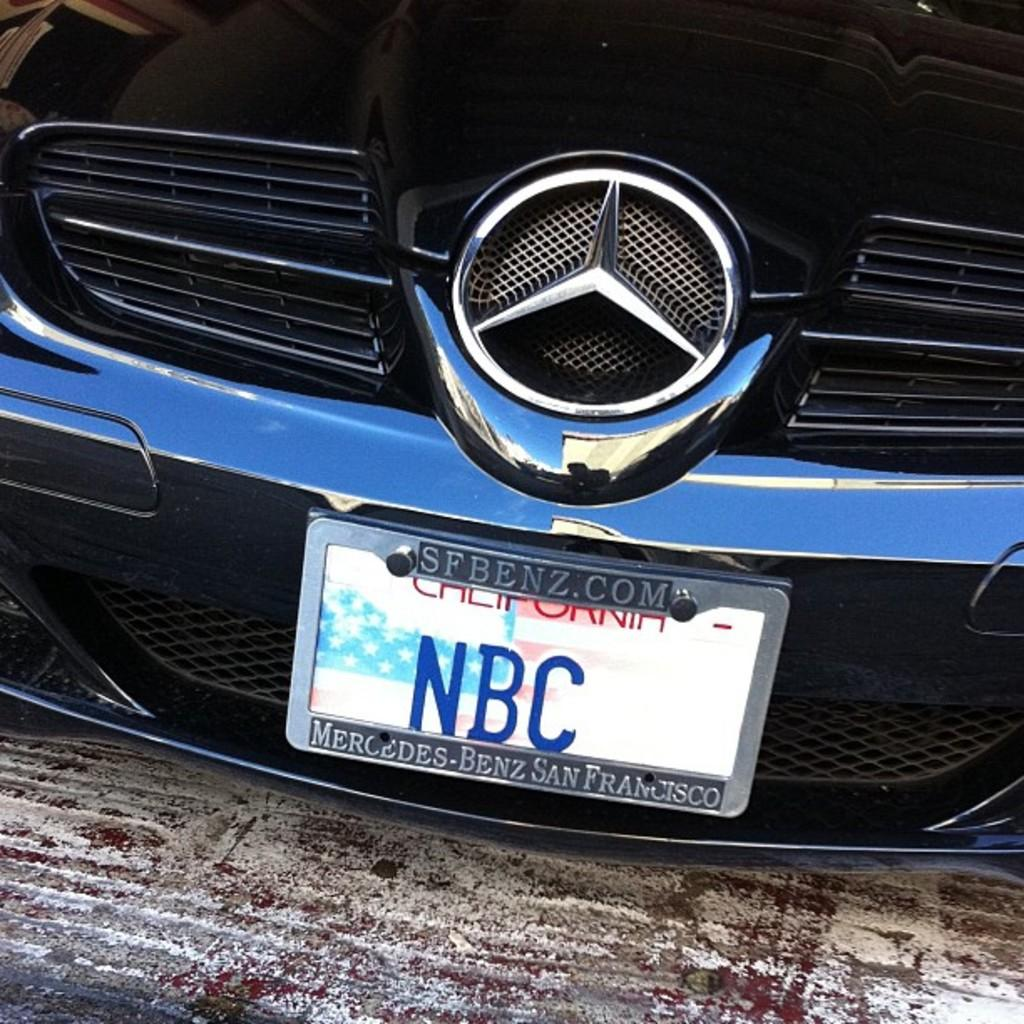What is the main subject of the image? The main subject of the image is a car. Does the car have any identifying features? Yes, the car has a logo and a registration plate. Where is the registration plate located in the image? The registration plate is on the ground in the image. Can you tell me the color of the vein in the image? There is no vein present in the image; it features a car with a logo and a registration plate. What type of hose is connected to the car in the image? There is no hose connected to the car in the image. 